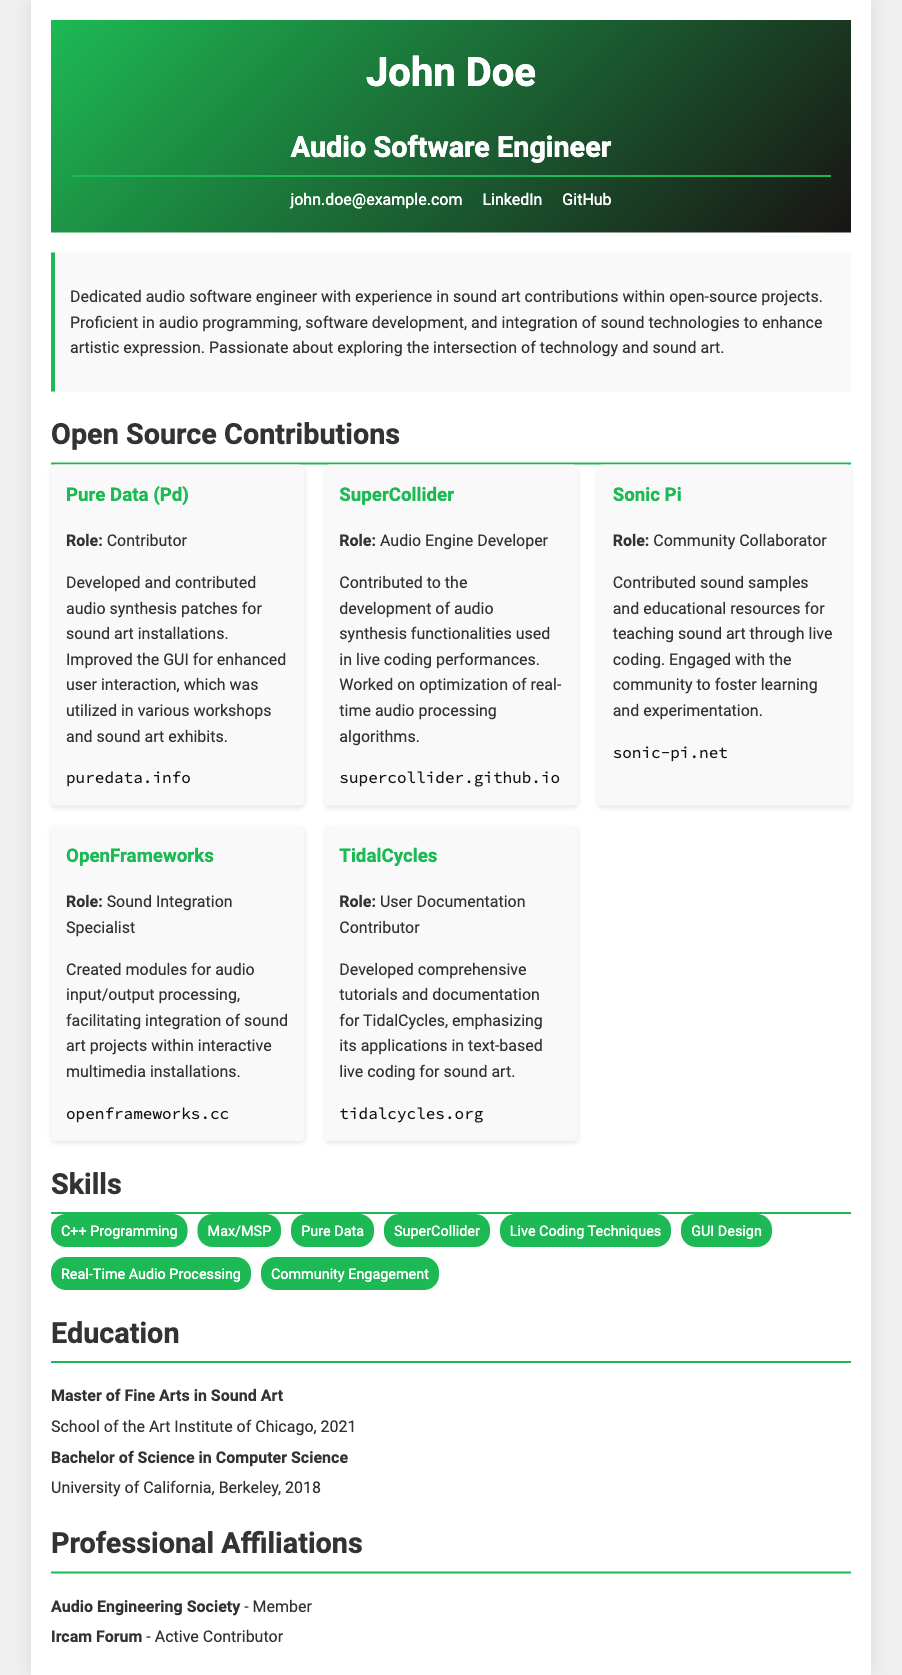what is the name of the CV holder? The name given in the document header is John Doe.
Answer: John Doe what is the role of the holder? The main title provided in the document describes him as an Audio Software Engineer.
Answer: Audio Software Engineer how many years of experience does the holder have in sound art contributions? The document states that he is dedicated and experienced in sound art contributions, but does not specify years; however, he received his master's degree in 2021.
Answer: Not specified which open-source project did he contribute to for audio synthesis patches? The document mentions the Pure Data (Pd) as the project where he developed and contributed audio synthesis patches.
Answer: Pure Data (Pd) what is the role he held in the SuperCollider project? The document states that he served as an Audio Engine Developer within the SuperCollider project.
Answer: Audio Engine Developer how many projects are listed under Open Source Contributions? The document lists five distinct open-source contributions by the holder.
Answer: Five what is the primary focus of his master’s degree? The degree mentioned in the document is a Master of Fine Arts in Sound Art.
Answer: Sound Art which community is he an active contributor to? According to the professional affiliations section, he is an active contributor to the Ircam Forum.
Answer: Ircam Forum what module type did he create for OpenFrameworks? The document indicates he created modules for audio input/output processing.
Answer: Audio input/output processing 